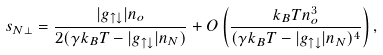<formula> <loc_0><loc_0><loc_500><loc_500>s _ { N \perp } = \frac { | g _ { \uparrow \downarrow } | n _ { o } } { 2 ( \gamma k _ { B } T - | g _ { \uparrow \downarrow } | n _ { N } ) } + O \left ( \frac { k _ { B } T n _ { o } ^ { 3 } } { ( \gamma k _ { B } T - | g _ { \uparrow \downarrow } | n _ { N } ) ^ { 4 } } \right ) ,</formula> 